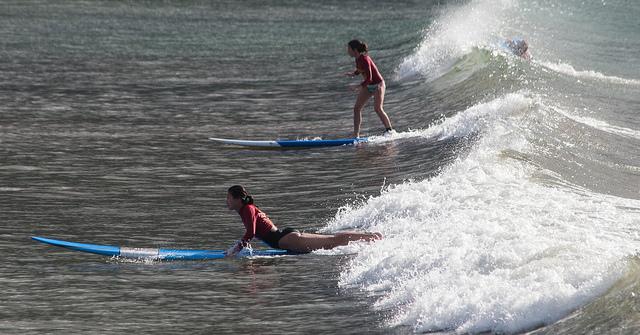Are they both standing on their boards?
Give a very brief answer. No. Where are they?
Short answer required. Ocean. What kind of sport are the practicing?
Concise answer only. Surfing. How many humans are in the image?
Be succinct. 3. 